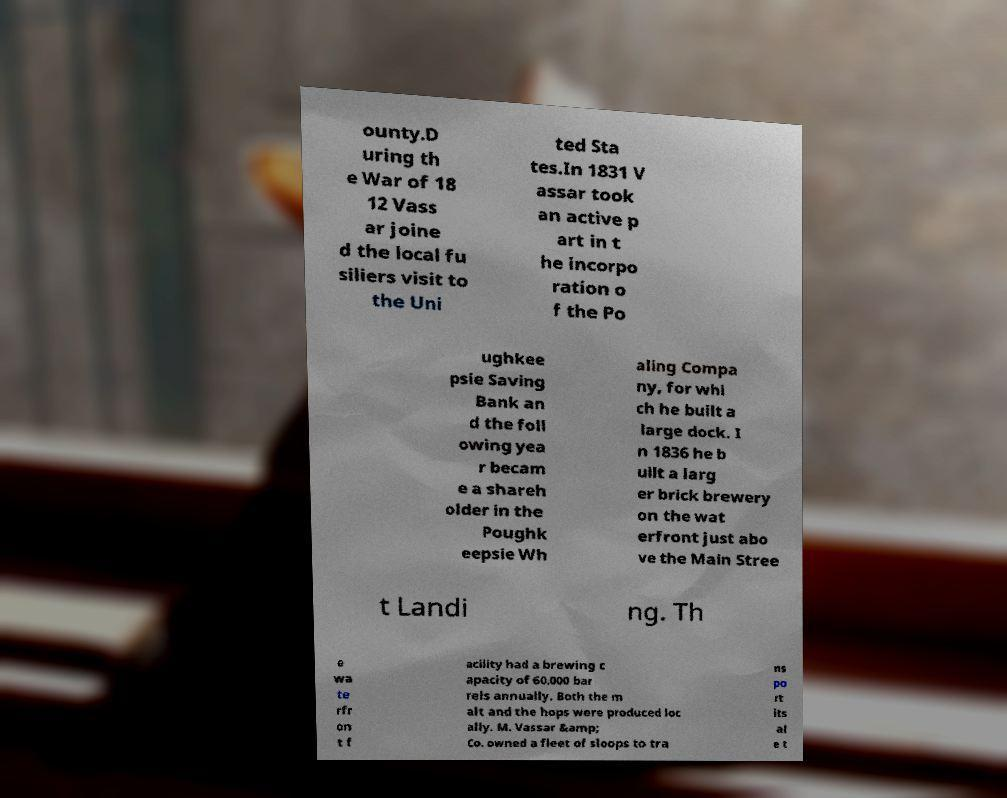Please read and relay the text visible in this image. What does it say? ounty.D uring th e War of 18 12 Vass ar joine d the local fu siliers visit to the Uni ted Sta tes.In 1831 V assar took an active p art in t he incorpo ration o f the Po ughkee psie Saving Bank an d the foll owing yea r becam e a shareh older in the Poughk eepsie Wh aling Compa ny, for whi ch he built a large dock. I n 1836 he b uilt a larg er brick brewery on the wat erfront just abo ve the Main Stree t Landi ng. Th e wa te rfr on t f acility had a brewing c apacity of 60,000 bar rels annually. Both the m alt and the hops were produced loc ally. M. Vassar &amp; Co. owned a fleet of sloops to tra ns po rt its al e t 